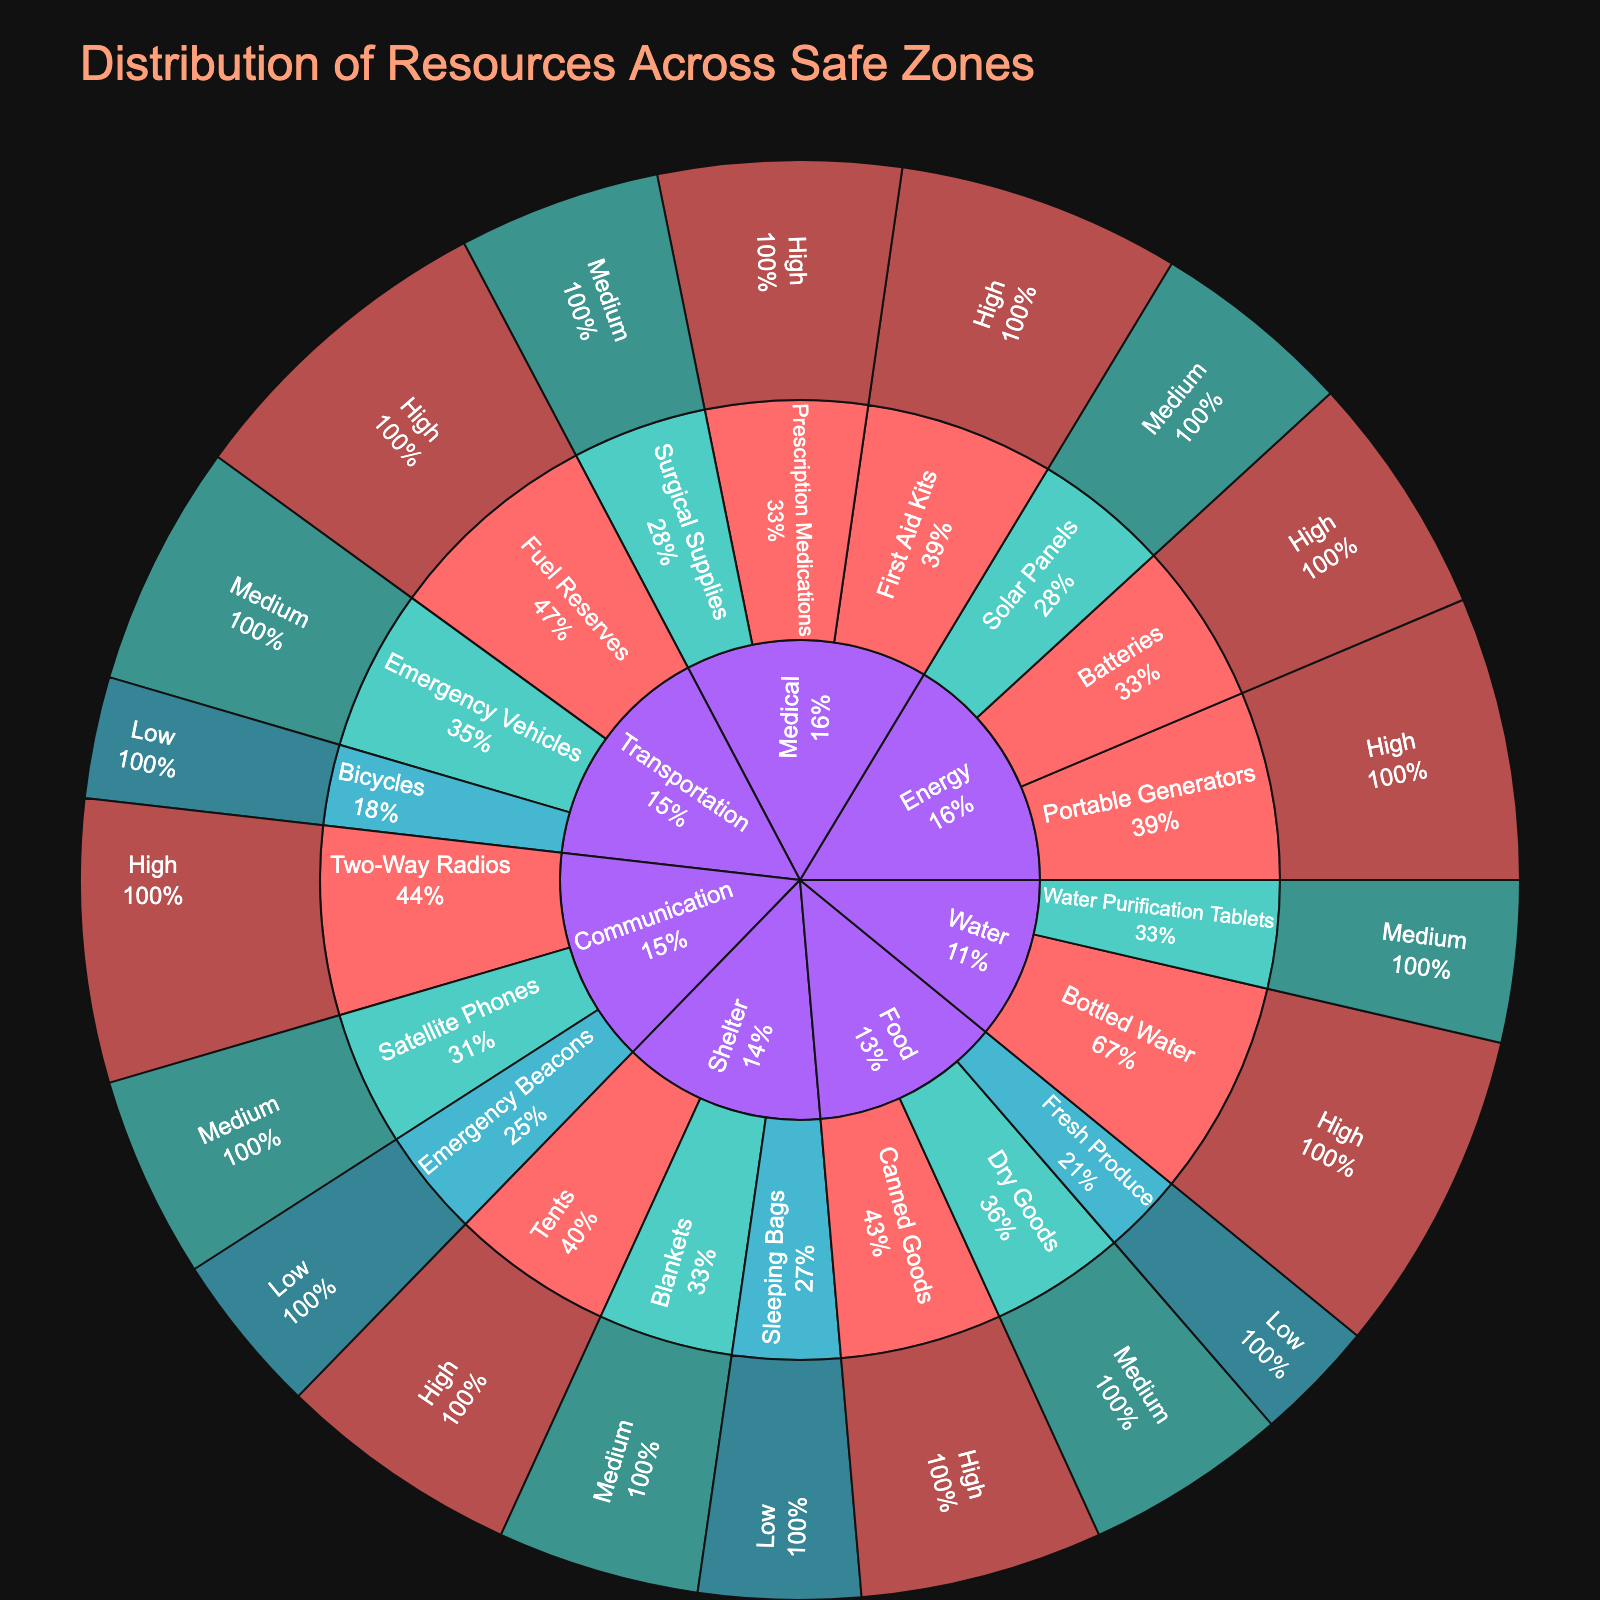What is the title of the plot? The title is displayed at the top of the plot, indicating what the visualization represents.
Answer: Distribution of Resources Across Safe Zones Which category has the highest total value of resources? To find the category with the highest total value, sum the values of each resource type within each category. Food: 70, Water: 60, Medical: 90, Shelter: 75, Energy: 90, Communication: 80, Transportation: 85
Answer: Medical and Energy (both 90) What percentage of the Food category does Canned Goods represent? Look at the sunburst plot, identify the percentage value of Canned Goods within the Food category.
Answer: 30/70 = 42.9% How many High priority resources are there across all categories? Count the number of resource types labeled as High priority in the plot.
Answer: 9 Which type within the Medical category has the second highest value? Within the Medical category, compare the values of each type and identify the second highest.
Answer: Prescription Medications Are there more Medium priority resources in Shelter or Energy? Compare the sum of Medium priority resources in both Shelter and Energy categories. Shelter: 25; Energy: 25
Answer: Equal (both 25) What is the total value of Low priority resources across all categories? Sum the values of all resources labeled as Low priority across all categories.
Answer: 15 + 20 + 20 + 15 = 70 What type within Transportation has the highest value? Identify the type within Transportation with the highest value by looking at the plot.
Answer: Fuel Reserves Is there any category that has resources only of High priority? Examine each category to see if any have only High priority resources.
Answer: No Which category has the least total value and what is it? Calculate the total value of resources for each category and identify the one with the lowest sum. Food: 70, Water: 60, Medical: 90, Shelter: 75, Energy: 90, Communication: 80, Transportation: 85
Answer: Water (60) 